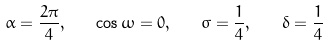<formula> <loc_0><loc_0><loc_500><loc_500>\alpha = \frac { 2 \pi } { 4 } , \quad \cos \omega = 0 , \quad \sigma = \frac { 1 } { 4 } , \quad \delta = \frac { 1 } { 4 }</formula> 